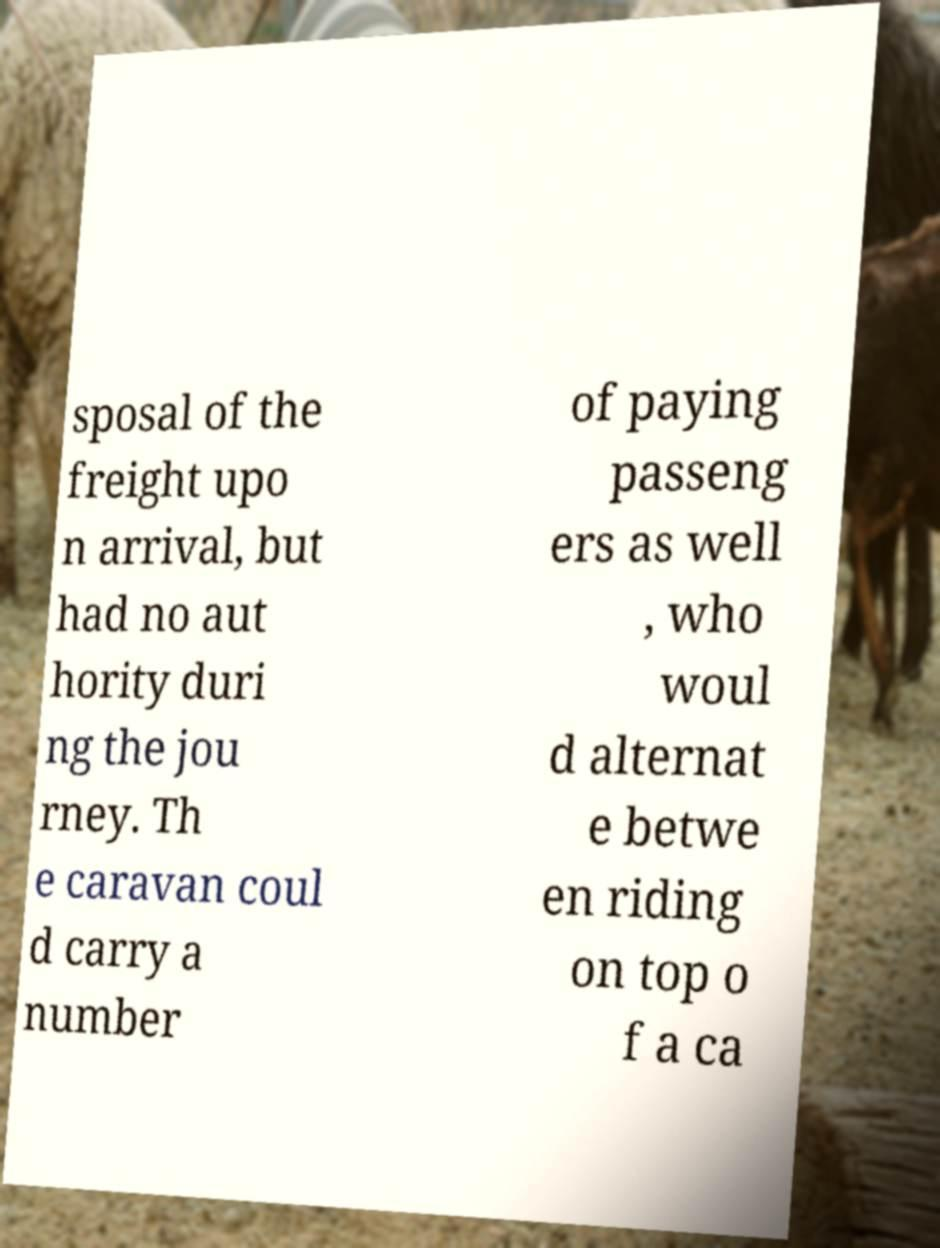For documentation purposes, I need the text within this image transcribed. Could you provide that? sposal of the freight upo n arrival, but had no aut hority duri ng the jou rney. Th e caravan coul d carry a number of paying passeng ers as well , who woul d alternat e betwe en riding on top o f a ca 